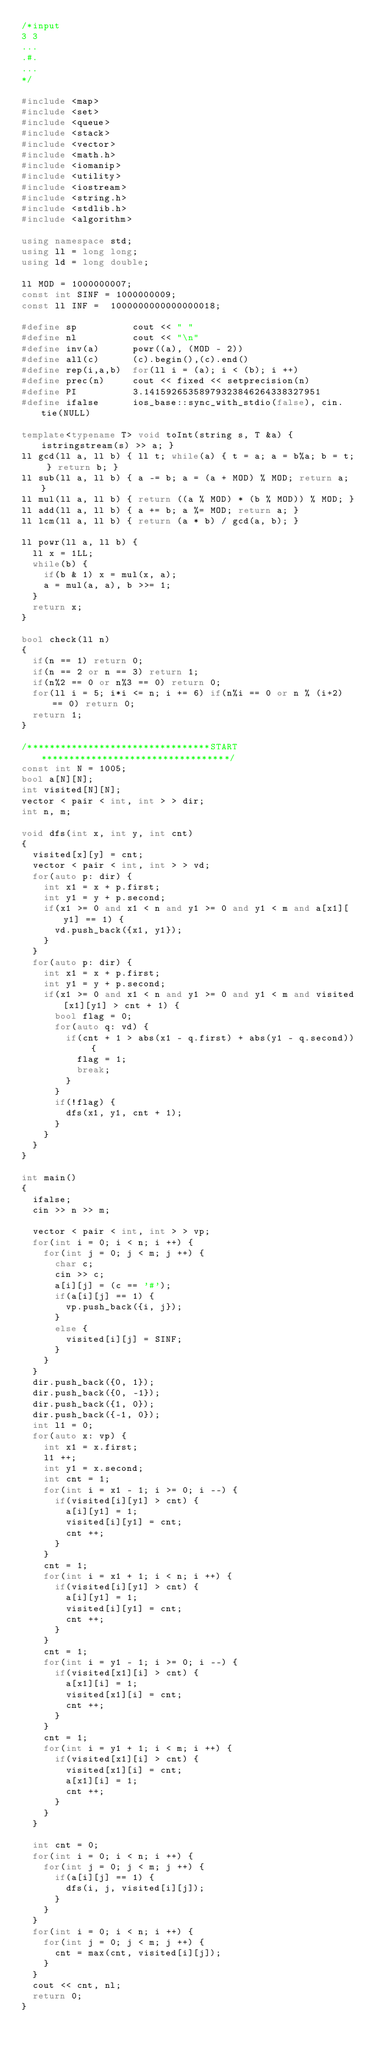<code> <loc_0><loc_0><loc_500><loc_500><_C++_>/*input
3 3
...
.#.
...
*/

#include <map>
#include <set>
#include <queue>
#include <stack>
#include <vector>
#include <math.h>
#include <iomanip>
#include <utility>
#include <iostream>
#include <string.h>
#include <stdlib.h>
#include <algorithm>

using namespace std;
using ll = long long;
using ld = long double;

ll MOD = 1000000007;
const int SINF = 1000000009;
const ll INF =  1000000000000000018;

#define sp          cout << " "
#define nl          cout << "\n"
#define inv(a)      powr((a), (MOD - 2))
#define all(c)      (c).begin(),(c).end()
#define rep(i,a,b)  for(ll i = (a); i < (b); i ++)
#define prec(n)     cout << fixed << setprecision(n)
#define PI          3.14159265358979323846264338327951
#define ifalse      ios_base::sync_with_stdio(false), cin.tie(NULL)

template<typename T> void toInt(string s, T &a) { istringstream(s) >> a; }
ll gcd(ll a, ll b) { ll t; while(a) { t = a; a = b%a; b = t; } return b; }
ll sub(ll a, ll b) { a -= b; a = (a + MOD) % MOD; return a; }
ll mul(ll a, ll b) { return ((a % MOD) * (b % MOD)) % MOD; }
ll add(ll a, ll b) { a += b; a %= MOD; return a; }
ll lcm(ll a, ll b) { return (a * b) / gcd(a, b); }

ll powr(ll a, ll b) {
  ll x = 1LL;
  while(b) {
    if(b & 1) x = mul(x, a);
    a = mul(a, a), b >>= 1;
  }
  return x;
}

bool check(ll n)
{
  if(n == 1) return 0;
  if(n == 2 or n == 3) return 1;
  if(n%2 == 0 or n%3 == 0) return 0;
  for(ll i = 5; i*i <= n; i += 6) if(n%i == 0 or n % (i+2) == 0) return 0;
  return 1;
}

/*********************************START**********************************/
const int N = 1005;
bool a[N][N];
int visited[N][N];
vector < pair < int, int > > dir;
int n, m;

void dfs(int x, int y, int cnt)
{
  visited[x][y] = cnt;
  vector < pair < int, int > > vd;
  for(auto p: dir) {
    int x1 = x + p.first;
    int y1 = y + p.second;
    if(x1 >= 0 and x1 < n and y1 >= 0 and y1 < m and a[x1][y1] == 1) {
      vd.push_back({x1, y1});
    }
  }
  for(auto p: dir) {
    int x1 = x + p.first;
    int y1 = y + p.second;
    if(x1 >= 0 and x1 < n and y1 >= 0 and y1 < m and visited[x1][y1] > cnt + 1) {
      bool flag = 0;
      for(auto q: vd) {
        if(cnt + 1 > abs(x1 - q.first) + abs(y1 - q.second)) {
          flag = 1;
          break;
        }
      }
      if(!flag) {
        dfs(x1, y1, cnt + 1);
      }
    }
  }
}

int main()
{
  ifalse;
  cin >> n >> m;

  vector < pair < int, int > > vp;
  for(int i = 0; i < n; i ++) {
    for(int j = 0; j < m; j ++) {
      char c;
      cin >> c;
      a[i][j] = (c == '#');
      if(a[i][j] == 1) {
        vp.push_back({i, j});
      }
      else {
        visited[i][j] = SINF;
      }
    }
  }
  dir.push_back({0, 1});
  dir.push_back({0, -1});
  dir.push_back({1, 0});
  dir.push_back({-1, 0});
  int l1 = 0;
  for(auto x: vp) {
    int x1 = x.first;
    l1 ++;
    int y1 = x.second;
    int cnt = 1;
    for(int i = x1 - 1; i >= 0; i --) {
      if(visited[i][y1] > cnt) {
        a[i][y1] = 1;
        visited[i][y1] = cnt;
        cnt ++;
      }
    }
    cnt = 1;
    for(int i = x1 + 1; i < n; i ++) {
      if(visited[i][y1] > cnt) {
        a[i][y1] = 1;
        visited[i][y1] = cnt;
        cnt ++;
      }
    }
    cnt = 1;
    for(int i = y1 - 1; i >= 0; i --) {
      if(visited[x1][i] > cnt) {
        a[x1][i] = 1;
        visited[x1][i] = cnt;
        cnt ++;
      }
    }
    cnt = 1;
    for(int i = y1 + 1; i < m; i ++) {
      if(visited[x1][i] > cnt) {
        visited[x1][i] = cnt;
        a[x1][i] = 1;
        cnt ++;
      }
    }
  }

  int cnt = 0;
  for(int i = 0; i < n; i ++) {
    for(int j = 0; j < m; j ++) {
      if(a[i][j] == 1) {
        dfs(i, j, visited[i][j]);
      }
    }
  }
  for(int i = 0; i < n; i ++) {
    for(int j = 0; j < m; j ++) {
      cnt = max(cnt, visited[i][j]);
    }
  }
  cout << cnt, nl;
  return 0;
}</code> 